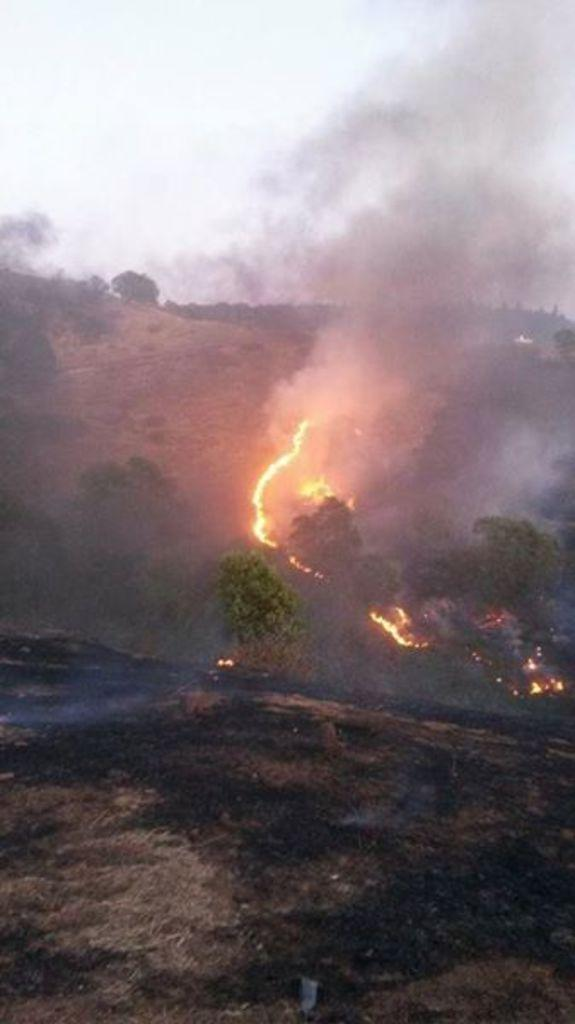What type of vegetation can be seen in the image? There are trees in the image. What is happening to the trees in the image? The trees are on fire. What can be seen in the background of the image? The sky is visible in the background of the image. What type of religion is being practiced by the boy in the image? There is no boy present in the image, and therefore no religious practice can be observed. 